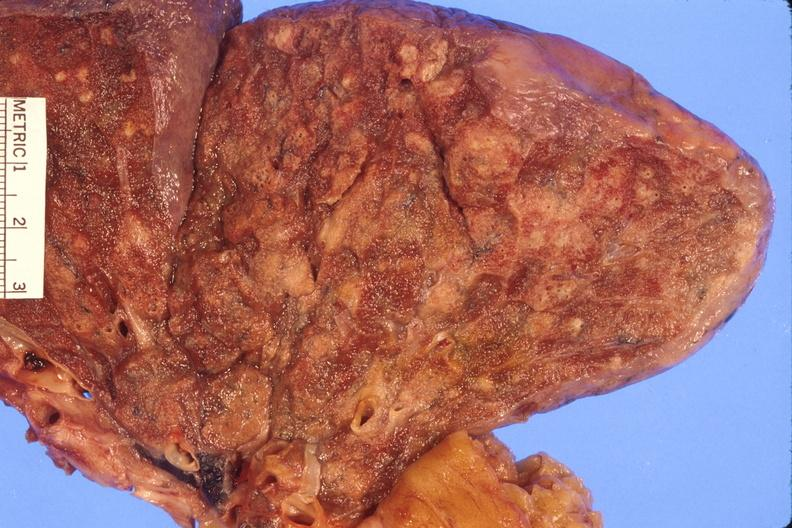s respiratory present?
Answer the question using a single word or phrase. Yes 